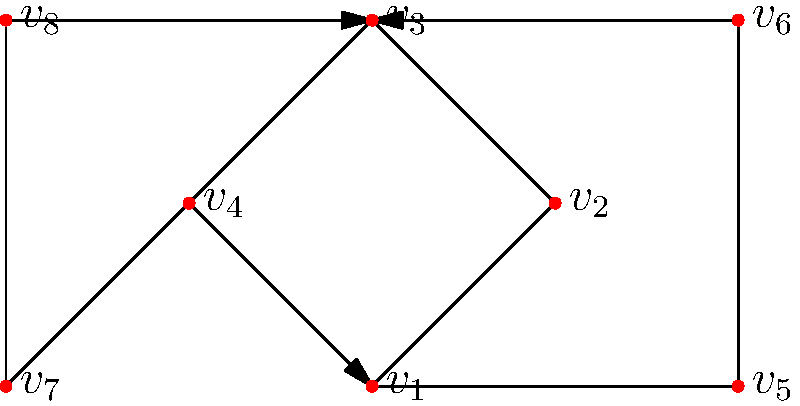In the LGBTQ+ activist network shown above, which vertex has the highest betweenness centrality? Explain your reasoning and calculate the betweenness centrality for the vertex you identify as having the highest value. To determine the vertex with the highest betweenness centrality, we need to follow these steps:

1. Betweenness centrality measures how often a node appears on the shortest paths between other nodes in the network.

2. For each vertex, we need to calculate:
   $C_B(v) = \sum_{s \neq v \neq t} \frac{\sigma_{st}(v)}{\sigma_{st}}$
   where $\sigma_{st}$ is the total number of shortest paths from node $s$ to node $t$, and $\sigma_{st}(v)$ is the number of those paths that pass through $v$.

3. Looking at the network, we can see that $v_3$ appears to be central and connects different parts of the network.

4. Let's calculate the betweenness centrality for $v_3$:
   - Pairs that must pass through $v_3$: $(v_1, v_6)$, $(v_1, v_8)$, $(v_2, v_6)$, $(v_2, v_8)$, $(v_4, v_5)$, $(v_4, v_6)$, $(v_5, v_7)$, $(v_6, v_7)$, $(v_7, v_8)$
   - For each of these 9 pairs, there is only one shortest path, and it passes through $v_3$
   - So, for each pair, $\frac{\sigma_{st}(v_3)}{\sigma_{st}} = 1$

5. Therefore, the betweenness centrality of $v_3$ is:
   $C_B(v_3) = 9$

6. No other vertex in the network would have a higher betweenness centrality, as $v_3$ is crucial for connecting different parts of the network.
Answer: $v_3$ with betweenness centrality of 9 